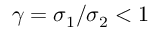Convert formula to latex. <formula><loc_0><loc_0><loc_500><loc_500>\gamma = \sigma _ { 1 } / \sigma _ { 2 } < 1</formula> 